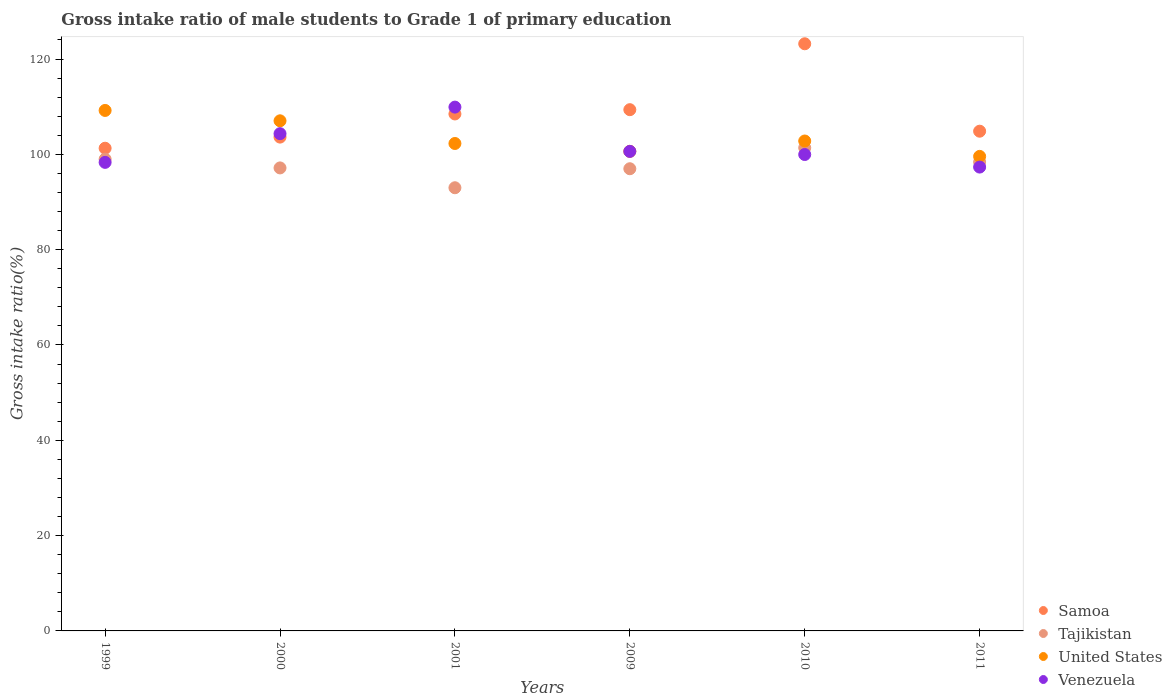How many different coloured dotlines are there?
Ensure brevity in your answer.  4. What is the gross intake ratio in Samoa in 2011?
Make the answer very short. 104.86. Across all years, what is the maximum gross intake ratio in United States?
Give a very brief answer. 109.21. Across all years, what is the minimum gross intake ratio in Samoa?
Your answer should be compact. 101.29. In which year was the gross intake ratio in Venezuela maximum?
Your response must be concise. 2001. In which year was the gross intake ratio in Samoa minimum?
Make the answer very short. 1999. What is the total gross intake ratio in Samoa in the graph?
Make the answer very short. 650.83. What is the difference between the gross intake ratio in Samoa in 2000 and that in 2001?
Your answer should be compact. -4.86. What is the difference between the gross intake ratio in Tajikistan in 1999 and the gross intake ratio in Samoa in 2010?
Provide a succinct answer. -24.21. What is the average gross intake ratio in United States per year?
Give a very brief answer. 103.59. In the year 1999, what is the difference between the gross intake ratio in Tajikistan and gross intake ratio in United States?
Your answer should be very brief. -10.22. In how many years, is the gross intake ratio in Tajikistan greater than 20 %?
Ensure brevity in your answer.  6. What is the ratio of the gross intake ratio in Venezuela in 2001 to that in 2009?
Keep it short and to the point. 1.09. Is the gross intake ratio in United States in 2009 less than that in 2010?
Provide a succinct answer. Yes. Is the difference between the gross intake ratio in Tajikistan in 1999 and 2000 greater than the difference between the gross intake ratio in United States in 1999 and 2000?
Give a very brief answer. No. What is the difference between the highest and the second highest gross intake ratio in Tajikistan?
Offer a terse response. 2.38. What is the difference between the highest and the lowest gross intake ratio in Samoa?
Offer a very short reply. 21.92. Is the sum of the gross intake ratio in Samoa in 1999 and 2011 greater than the maximum gross intake ratio in Venezuela across all years?
Your answer should be compact. Yes. Is it the case that in every year, the sum of the gross intake ratio in Samoa and gross intake ratio in Venezuela  is greater than the sum of gross intake ratio in Tajikistan and gross intake ratio in United States?
Keep it short and to the point. No. How many dotlines are there?
Offer a very short reply. 4. How many years are there in the graph?
Ensure brevity in your answer.  6. Are the values on the major ticks of Y-axis written in scientific E-notation?
Give a very brief answer. No. Does the graph contain grids?
Ensure brevity in your answer.  No. How are the legend labels stacked?
Provide a short and direct response. Vertical. What is the title of the graph?
Give a very brief answer. Gross intake ratio of male students to Grade 1 of primary education. What is the label or title of the Y-axis?
Offer a terse response. Gross intake ratio(%). What is the Gross intake ratio(%) in Samoa in 1999?
Keep it short and to the point. 101.29. What is the Gross intake ratio(%) of Tajikistan in 1999?
Offer a terse response. 98.99. What is the Gross intake ratio(%) of United States in 1999?
Your answer should be very brief. 109.21. What is the Gross intake ratio(%) of Venezuela in 1999?
Make the answer very short. 98.32. What is the Gross intake ratio(%) in Samoa in 2000?
Your answer should be compact. 103.62. What is the Gross intake ratio(%) of Tajikistan in 2000?
Provide a succinct answer. 97.15. What is the Gross intake ratio(%) in United States in 2000?
Make the answer very short. 107.04. What is the Gross intake ratio(%) in Venezuela in 2000?
Provide a succinct answer. 104.34. What is the Gross intake ratio(%) in Samoa in 2001?
Your answer should be compact. 108.48. What is the Gross intake ratio(%) in Tajikistan in 2001?
Keep it short and to the point. 92.99. What is the Gross intake ratio(%) in United States in 2001?
Ensure brevity in your answer.  102.28. What is the Gross intake ratio(%) of Venezuela in 2001?
Provide a short and direct response. 109.91. What is the Gross intake ratio(%) in Samoa in 2009?
Keep it short and to the point. 109.38. What is the Gross intake ratio(%) of Tajikistan in 2009?
Your answer should be compact. 96.98. What is the Gross intake ratio(%) in United States in 2009?
Offer a very short reply. 100.63. What is the Gross intake ratio(%) of Venezuela in 2009?
Give a very brief answer. 100.62. What is the Gross intake ratio(%) of Samoa in 2010?
Offer a terse response. 123.2. What is the Gross intake ratio(%) in Tajikistan in 2010?
Provide a succinct answer. 101.38. What is the Gross intake ratio(%) of United States in 2010?
Offer a terse response. 102.8. What is the Gross intake ratio(%) of Venezuela in 2010?
Give a very brief answer. 99.97. What is the Gross intake ratio(%) of Samoa in 2011?
Give a very brief answer. 104.86. What is the Gross intake ratio(%) of Tajikistan in 2011?
Offer a very short reply. 98.4. What is the Gross intake ratio(%) of United States in 2011?
Offer a terse response. 99.57. What is the Gross intake ratio(%) in Venezuela in 2011?
Offer a very short reply. 97.33. Across all years, what is the maximum Gross intake ratio(%) of Samoa?
Ensure brevity in your answer.  123.2. Across all years, what is the maximum Gross intake ratio(%) of Tajikistan?
Your response must be concise. 101.38. Across all years, what is the maximum Gross intake ratio(%) of United States?
Provide a succinct answer. 109.21. Across all years, what is the maximum Gross intake ratio(%) in Venezuela?
Your response must be concise. 109.91. Across all years, what is the minimum Gross intake ratio(%) in Samoa?
Keep it short and to the point. 101.29. Across all years, what is the minimum Gross intake ratio(%) in Tajikistan?
Your answer should be very brief. 92.99. Across all years, what is the minimum Gross intake ratio(%) in United States?
Provide a succinct answer. 99.57. Across all years, what is the minimum Gross intake ratio(%) in Venezuela?
Keep it short and to the point. 97.33. What is the total Gross intake ratio(%) of Samoa in the graph?
Offer a very short reply. 650.83. What is the total Gross intake ratio(%) in Tajikistan in the graph?
Offer a very short reply. 585.9. What is the total Gross intake ratio(%) of United States in the graph?
Ensure brevity in your answer.  621.55. What is the total Gross intake ratio(%) of Venezuela in the graph?
Keep it short and to the point. 610.5. What is the difference between the Gross intake ratio(%) in Samoa in 1999 and that in 2000?
Your answer should be compact. -2.33. What is the difference between the Gross intake ratio(%) of Tajikistan in 1999 and that in 2000?
Your answer should be compact. 1.84. What is the difference between the Gross intake ratio(%) in United States in 1999 and that in 2000?
Keep it short and to the point. 2.17. What is the difference between the Gross intake ratio(%) of Venezuela in 1999 and that in 2000?
Your answer should be very brief. -6.02. What is the difference between the Gross intake ratio(%) in Samoa in 1999 and that in 2001?
Your answer should be compact. -7.19. What is the difference between the Gross intake ratio(%) of Tajikistan in 1999 and that in 2001?
Keep it short and to the point. 6. What is the difference between the Gross intake ratio(%) of United States in 1999 and that in 2001?
Give a very brief answer. 6.93. What is the difference between the Gross intake ratio(%) in Venezuela in 1999 and that in 2001?
Offer a terse response. -11.59. What is the difference between the Gross intake ratio(%) of Samoa in 1999 and that in 2009?
Your answer should be compact. -8.09. What is the difference between the Gross intake ratio(%) in Tajikistan in 1999 and that in 2009?
Provide a succinct answer. 2.01. What is the difference between the Gross intake ratio(%) in United States in 1999 and that in 2009?
Your response must be concise. 8.58. What is the difference between the Gross intake ratio(%) of Venezuela in 1999 and that in 2009?
Provide a succinct answer. -2.31. What is the difference between the Gross intake ratio(%) of Samoa in 1999 and that in 2010?
Make the answer very short. -21.92. What is the difference between the Gross intake ratio(%) in Tajikistan in 1999 and that in 2010?
Your answer should be very brief. -2.38. What is the difference between the Gross intake ratio(%) in United States in 1999 and that in 2010?
Offer a very short reply. 6.41. What is the difference between the Gross intake ratio(%) in Venezuela in 1999 and that in 2010?
Your answer should be compact. -1.65. What is the difference between the Gross intake ratio(%) of Samoa in 1999 and that in 2011?
Provide a succinct answer. -3.57. What is the difference between the Gross intake ratio(%) of Tajikistan in 1999 and that in 2011?
Your answer should be very brief. 0.6. What is the difference between the Gross intake ratio(%) in United States in 1999 and that in 2011?
Provide a short and direct response. 9.64. What is the difference between the Gross intake ratio(%) in Samoa in 2000 and that in 2001?
Ensure brevity in your answer.  -4.86. What is the difference between the Gross intake ratio(%) of Tajikistan in 2000 and that in 2001?
Give a very brief answer. 4.16. What is the difference between the Gross intake ratio(%) in United States in 2000 and that in 2001?
Your answer should be compact. 4.76. What is the difference between the Gross intake ratio(%) of Venezuela in 2000 and that in 2001?
Keep it short and to the point. -5.57. What is the difference between the Gross intake ratio(%) of Samoa in 2000 and that in 2009?
Provide a short and direct response. -5.75. What is the difference between the Gross intake ratio(%) of Tajikistan in 2000 and that in 2009?
Make the answer very short. 0.17. What is the difference between the Gross intake ratio(%) of United States in 2000 and that in 2009?
Provide a succinct answer. 6.41. What is the difference between the Gross intake ratio(%) of Venezuela in 2000 and that in 2009?
Your response must be concise. 3.72. What is the difference between the Gross intake ratio(%) of Samoa in 2000 and that in 2010?
Offer a terse response. -19.58. What is the difference between the Gross intake ratio(%) of Tajikistan in 2000 and that in 2010?
Your response must be concise. -4.22. What is the difference between the Gross intake ratio(%) in United States in 2000 and that in 2010?
Your answer should be very brief. 4.24. What is the difference between the Gross intake ratio(%) of Venezuela in 2000 and that in 2010?
Provide a short and direct response. 4.37. What is the difference between the Gross intake ratio(%) in Samoa in 2000 and that in 2011?
Give a very brief answer. -1.24. What is the difference between the Gross intake ratio(%) in Tajikistan in 2000 and that in 2011?
Your answer should be very brief. -1.24. What is the difference between the Gross intake ratio(%) of United States in 2000 and that in 2011?
Make the answer very short. 7.47. What is the difference between the Gross intake ratio(%) in Venezuela in 2000 and that in 2011?
Your answer should be very brief. 7.01. What is the difference between the Gross intake ratio(%) in Samoa in 2001 and that in 2009?
Provide a short and direct response. -0.9. What is the difference between the Gross intake ratio(%) in Tajikistan in 2001 and that in 2009?
Ensure brevity in your answer.  -3.99. What is the difference between the Gross intake ratio(%) in United States in 2001 and that in 2009?
Provide a short and direct response. 1.65. What is the difference between the Gross intake ratio(%) in Venezuela in 2001 and that in 2009?
Give a very brief answer. 9.29. What is the difference between the Gross intake ratio(%) of Samoa in 2001 and that in 2010?
Offer a very short reply. -14.73. What is the difference between the Gross intake ratio(%) in Tajikistan in 2001 and that in 2010?
Ensure brevity in your answer.  -8.38. What is the difference between the Gross intake ratio(%) in United States in 2001 and that in 2010?
Offer a terse response. -0.52. What is the difference between the Gross intake ratio(%) of Venezuela in 2001 and that in 2010?
Your response must be concise. 9.94. What is the difference between the Gross intake ratio(%) of Samoa in 2001 and that in 2011?
Offer a very short reply. 3.62. What is the difference between the Gross intake ratio(%) in Tajikistan in 2001 and that in 2011?
Ensure brevity in your answer.  -5.4. What is the difference between the Gross intake ratio(%) of United States in 2001 and that in 2011?
Make the answer very short. 2.71. What is the difference between the Gross intake ratio(%) of Venezuela in 2001 and that in 2011?
Provide a succinct answer. 12.58. What is the difference between the Gross intake ratio(%) of Samoa in 2009 and that in 2010?
Your answer should be very brief. -13.83. What is the difference between the Gross intake ratio(%) in Tajikistan in 2009 and that in 2010?
Offer a terse response. -4.39. What is the difference between the Gross intake ratio(%) of United States in 2009 and that in 2010?
Your answer should be compact. -2.17. What is the difference between the Gross intake ratio(%) of Venezuela in 2009 and that in 2010?
Keep it short and to the point. 0.66. What is the difference between the Gross intake ratio(%) of Samoa in 2009 and that in 2011?
Your answer should be very brief. 4.51. What is the difference between the Gross intake ratio(%) of Tajikistan in 2009 and that in 2011?
Keep it short and to the point. -1.41. What is the difference between the Gross intake ratio(%) in United States in 2009 and that in 2011?
Offer a very short reply. 1.06. What is the difference between the Gross intake ratio(%) in Venezuela in 2009 and that in 2011?
Provide a short and direct response. 3.29. What is the difference between the Gross intake ratio(%) of Samoa in 2010 and that in 2011?
Give a very brief answer. 18.34. What is the difference between the Gross intake ratio(%) in Tajikistan in 2010 and that in 2011?
Ensure brevity in your answer.  2.98. What is the difference between the Gross intake ratio(%) in United States in 2010 and that in 2011?
Offer a very short reply. 3.23. What is the difference between the Gross intake ratio(%) of Venezuela in 2010 and that in 2011?
Make the answer very short. 2.64. What is the difference between the Gross intake ratio(%) of Samoa in 1999 and the Gross intake ratio(%) of Tajikistan in 2000?
Keep it short and to the point. 4.13. What is the difference between the Gross intake ratio(%) of Samoa in 1999 and the Gross intake ratio(%) of United States in 2000?
Your response must be concise. -5.75. What is the difference between the Gross intake ratio(%) of Samoa in 1999 and the Gross intake ratio(%) of Venezuela in 2000?
Ensure brevity in your answer.  -3.05. What is the difference between the Gross intake ratio(%) in Tajikistan in 1999 and the Gross intake ratio(%) in United States in 2000?
Offer a very short reply. -8.05. What is the difference between the Gross intake ratio(%) of Tajikistan in 1999 and the Gross intake ratio(%) of Venezuela in 2000?
Make the answer very short. -5.35. What is the difference between the Gross intake ratio(%) in United States in 1999 and the Gross intake ratio(%) in Venezuela in 2000?
Keep it short and to the point. 4.87. What is the difference between the Gross intake ratio(%) of Samoa in 1999 and the Gross intake ratio(%) of Tajikistan in 2001?
Make the answer very short. 8.29. What is the difference between the Gross intake ratio(%) in Samoa in 1999 and the Gross intake ratio(%) in United States in 2001?
Provide a succinct answer. -0.99. What is the difference between the Gross intake ratio(%) in Samoa in 1999 and the Gross intake ratio(%) in Venezuela in 2001?
Provide a short and direct response. -8.62. What is the difference between the Gross intake ratio(%) in Tajikistan in 1999 and the Gross intake ratio(%) in United States in 2001?
Your response must be concise. -3.29. What is the difference between the Gross intake ratio(%) of Tajikistan in 1999 and the Gross intake ratio(%) of Venezuela in 2001?
Make the answer very short. -10.92. What is the difference between the Gross intake ratio(%) of United States in 1999 and the Gross intake ratio(%) of Venezuela in 2001?
Provide a short and direct response. -0.7. What is the difference between the Gross intake ratio(%) of Samoa in 1999 and the Gross intake ratio(%) of Tajikistan in 2009?
Your answer should be compact. 4.3. What is the difference between the Gross intake ratio(%) of Samoa in 1999 and the Gross intake ratio(%) of United States in 2009?
Make the answer very short. 0.65. What is the difference between the Gross intake ratio(%) of Samoa in 1999 and the Gross intake ratio(%) of Venezuela in 2009?
Give a very brief answer. 0.66. What is the difference between the Gross intake ratio(%) in Tajikistan in 1999 and the Gross intake ratio(%) in United States in 2009?
Give a very brief answer. -1.64. What is the difference between the Gross intake ratio(%) of Tajikistan in 1999 and the Gross intake ratio(%) of Venezuela in 2009?
Provide a short and direct response. -1.63. What is the difference between the Gross intake ratio(%) of United States in 1999 and the Gross intake ratio(%) of Venezuela in 2009?
Your answer should be very brief. 8.59. What is the difference between the Gross intake ratio(%) in Samoa in 1999 and the Gross intake ratio(%) in Tajikistan in 2010?
Ensure brevity in your answer.  -0.09. What is the difference between the Gross intake ratio(%) of Samoa in 1999 and the Gross intake ratio(%) of United States in 2010?
Your answer should be very brief. -1.51. What is the difference between the Gross intake ratio(%) of Samoa in 1999 and the Gross intake ratio(%) of Venezuela in 2010?
Your response must be concise. 1.32. What is the difference between the Gross intake ratio(%) in Tajikistan in 1999 and the Gross intake ratio(%) in United States in 2010?
Your response must be concise. -3.81. What is the difference between the Gross intake ratio(%) of Tajikistan in 1999 and the Gross intake ratio(%) of Venezuela in 2010?
Your answer should be very brief. -0.98. What is the difference between the Gross intake ratio(%) of United States in 1999 and the Gross intake ratio(%) of Venezuela in 2010?
Provide a short and direct response. 9.25. What is the difference between the Gross intake ratio(%) of Samoa in 1999 and the Gross intake ratio(%) of Tajikistan in 2011?
Provide a short and direct response. 2.89. What is the difference between the Gross intake ratio(%) of Samoa in 1999 and the Gross intake ratio(%) of United States in 2011?
Make the answer very short. 1.71. What is the difference between the Gross intake ratio(%) of Samoa in 1999 and the Gross intake ratio(%) of Venezuela in 2011?
Keep it short and to the point. 3.96. What is the difference between the Gross intake ratio(%) in Tajikistan in 1999 and the Gross intake ratio(%) in United States in 2011?
Keep it short and to the point. -0.58. What is the difference between the Gross intake ratio(%) in Tajikistan in 1999 and the Gross intake ratio(%) in Venezuela in 2011?
Offer a very short reply. 1.66. What is the difference between the Gross intake ratio(%) in United States in 1999 and the Gross intake ratio(%) in Venezuela in 2011?
Provide a short and direct response. 11.88. What is the difference between the Gross intake ratio(%) of Samoa in 2000 and the Gross intake ratio(%) of Tajikistan in 2001?
Make the answer very short. 10.63. What is the difference between the Gross intake ratio(%) of Samoa in 2000 and the Gross intake ratio(%) of United States in 2001?
Offer a terse response. 1.34. What is the difference between the Gross intake ratio(%) in Samoa in 2000 and the Gross intake ratio(%) in Venezuela in 2001?
Your response must be concise. -6.29. What is the difference between the Gross intake ratio(%) of Tajikistan in 2000 and the Gross intake ratio(%) of United States in 2001?
Provide a short and direct response. -5.13. What is the difference between the Gross intake ratio(%) of Tajikistan in 2000 and the Gross intake ratio(%) of Venezuela in 2001?
Provide a short and direct response. -12.76. What is the difference between the Gross intake ratio(%) in United States in 2000 and the Gross intake ratio(%) in Venezuela in 2001?
Provide a succinct answer. -2.87. What is the difference between the Gross intake ratio(%) in Samoa in 2000 and the Gross intake ratio(%) in Tajikistan in 2009?
Ensure brevity in your answer.  6.64. What is the difference between the Gross intake ratio(%) of Samoa in 2000 and the Gross intake ratio(%) of United States in 2009?
Offer a very short reply. 2.99. What is the difference between the Gross intake ratio(%) of Samoa in 2000 and the Gross intake ratio(%) of Venezuela in 2009?
Provide a short and direct response. 3. What is the difference between the Gross intake ratio(%) of Tajikistan in 2000 and the Gross intake ratio(%) of United States in 2009?
Ensure brevity in your answer.  -3.48. What is the difference between the Gross intake ratio(%) of Tajikistan in 2000 and the Gross intake ratio(%) of Venezuela in 2009?
Make the answer very short. -3.47. What is the difference between the Gross intake ratio(%) in United States in 2000 and the Gross intake ratio(%) in Venezuela in 2009?
Your response must be concise. 6.42. What is the difference between the Gross intake ratio(%) in Samoa in 2000 and the Gross intake ratio(%) in Tajikistan in 2010?
Offer a very short reply. 2.25. What is the difference between the Gross intake ratio(%) of Samoa in 2000 and the Gross intake ratio(%) of United States in 2010?
Your answer should be very brief. 0.82. What is the difference between the Gross intake ratio(%) of Samoa in 2000 and the Gross intake ratio(%) of Venezuela in 2010?
Your response must be concise. 3.65. What is the difference between the Gross intake ratio(%) of Tajikistan in 2000 and the Gross intake ratio(%) of United States in 2010?
Your answer should be compact. -5.65. What is the difference between the Gross intake ratio(%) in Tajikistan in 2000 and the Gross intake ratio(%) in Venezuela in 2010?
Make the answer very short. -2.81. What is the difference between the Gross intake ratio(%) in United States in 2000 and the Gross intake ratio(%) in Venezuela in 2010?
Ensure brevity in your answer.  7.07. What is the difference between the Gross intake ratio(%) in Samoa in 2000 and the Gross intake ratio(%) in Tajikistan in 2011?
Your answer should be very brief. 5.22. What is the difference between the Gross intake ratio(%) in Samoa in 2000 and the Gross intake ratio(%) in United States in 2011?
Your answer should be very brief. 4.05. What is the difference between the Gross intake ratio(%) in Samoa in 2000 and the Gross intake ratio(%) in Venezuela in 2011?
Provide a short and direct response. 6.29. What is the difference between the Gross intake ratio(%) of Tajikistan in 2000 and the Gross intake ratio(%) of United States in 2011?
Your answer should be compact. -2.42. What is the difference between the Gross intake ratio(%) in Tajikistan in 2000 and the Gross intake ratio(%) in Venezuela in 2011?
Make the answer very short. -0.18. What is the difference between the Gross intake ratio(%) of United States in 2000 and the Gross intake ratio(%) of Venezuela in 2011?
Provide a succinct answer. 9.71. What is the difference between the Gross intake ratio(%) in Samoa in 2001 and the Gross intake ratio(%) in Tajikistan in 2009?
Provide a short and direct response. 11.49. What is the difference between the Gross intake ratio(%) in Samoa in 2001 and the Gross intake ratio(%) in United States in 2009?
Provide a succinct answer. 7.84. What is the difference between the Gross intake ratio(%) of Samoa in 2001 and the Gross intake ratio(%) of Venezuela in 2009?
Ensure brevity in your answer.  7.85. What is the difference between the Gross intake ratio(%) of Tajikistan in 2001 and the Gross intake ratio(%) of United States in 2009?
Make the answer very short. -7.64. What is the difference between the Gross intake ratio(%) of Tajikistan in 2001 and the Gross intake ratio(%) of Venezuela in 2009?
Your answer should be compact. -7.63. What is the difference between the Gross intake ratio(%) in United States in 2001 and the Gross intake ratio(%) in Venezuela in 2009?
Keep it short and to the point. 1.66. What is the difference between the Gross intake ratio(%) in Samoa in 2001 and the Gross intake ratio(%) in Tajikistan in 2010?
Offer a terse response. 7.1. What is the difference between the Gross intake ratio(%) in Samoa in 2001 and the Gross intake ratio(%) in United States in 2010?
Your response must be concise. 5.68. What is the difference between the Gross intake ratio(%) of Samoa in 2001 and the Gross intake ratio(%) of Venezuela in 2010?
Your response must be concise. 8.51. What is the difference between the Gross intake ratio(%) of Tajikistan in 2001 and the Gross intake ratio(%) of United States in 2010?
Keep it short and to the point. -9.81. What is the difference between the Gross intake ratio(%) in Tajikistan in 2001 and the Gross intake ratio(%) in Venezuela in 2010?
Provide a succinct answer. -6.97. What is the difference between the Gross intake ratio(%) in United States in 2001 and the Gross intake ratio(%) in Venezuela in 2010?
Keep it short and to the point. 2.31. What is the difference between the Gross intake ratio(%) of Samoa in 2001 and the Gross intake ratio(%) of Tajikistan in 2011?
Keep it short and to the point. 10.08. What is the difference between the Gross intake ratio(%) of Samoa in 2001 and the Gross intake ratio(%) of United States in 2011?
Provide a short and direct response. 8.9. What is the difference between the Gross intake ratio(%) of Samoa in 2001 and the Gross intake ratio(%) of Venezuela in 2011?
Provide a succinct answer. 11.15. What is the difference between the Gross intake ratio(%) of Tajikistan in 2001 and the Gross intake ratio(%) of United States in 2011?
Offer a very short reply. -6.58. What is the difference between the Gross intake ratio(%) of Tajikistan in 2001 and the Gross intake ratio(%) of Venezuela in 2011?
Offer a terse response. -4.34. What is the difference between the Gross intake ratio(%) of United States in 2001 and the Gross intake ratio(%) of Venezuela in 2011?
Provide a short and direct response. 4.95. What is the difference between the Gross intake ratio(%) in Samoa in 2009 and the Gross intake ratio(%) in Tajikistan in 2010?
Keep it short and to the point. 8. What is the difference between the Gross intake ratio(%) of Samoa in 2009 and the Gross intake ratio(%) of United States in 2010?
Make the answer very short. 6.57. What is the difference between the Gross intake ratio(%) in Samoa in 2009 and the Gross intake ratio(%) in Venezuela in 2010?
Offer a terse response. 9.41. What is the difference between the Gross intake ratio(%) of Tajikistan in 2009 and the Gross intake ratio(%) of United States in 2010?
Ensure brevity in your answer.  -5.82. What is the difference between the Gross intake ratio(%) in Tajikistan in 2009 and the Gross intake ratio(%) in Venezuela in 2010?
Provide a short and direct response. -2.99. What is the difference between the Gross intake ratio(%) in United States in 2009 and the Gross intake ratio(%) in Venezuela in 2010?
Keep it short and to the point. 0.67. What is the difference between the Gross intake ratio(%) of Samoa in 2009 and the Gross intake ratio(%) of Tajikistan in 2011?
Give a very brief answer. 10.98. What is the difference between the Gross intake ratio(%) of Samoa in 2009 and the Gross intake ratio(%) of United States in 2011?
Ensure brevity in your answer.  9.8. What is the difference between the Gross intake ratio(%) in Samoa in 2009 and the Gross intake ratio(%) in Venezuela in 2011?
Your answer should be very brief. 12.04. What is the difference between the Gross intake ratio(%) of Tajikistan in 2009 and the Gross intake ratio(%) of United States in 2011?
Offer a very short reply. -2.59. What is the difference between the Gross intake ratio(%) in Tajikistan in 2009 and the Gross intake ratio(%) in Venezuela in 2011?
Offer a very short reply. -0.35. What is the difference between the Gross intake ratio(%) in United States in 2009 and the Gross intake ratio(%) in Venezuela in 2011?
Provide a short and direct response. 3.3. What is the difference between the Gross intake ratio(%) of Samoa in 2010 and the Gross intake ratio(%) of Tajikistan in 2011?
Give a very brief answer. 24.81. What is the difference between the Gross intake ratio(%) of Samoa in 2010 and the Gross intake ratio(%) of United States in 2011?
Keep it short and to the point. 23.63. What is the difference between the Gross intake ratio(%) in Samoa in 2010 and the Gross intake ratio(%) in Venezuela in 2011?
Provide a short and direct response. 25.87. What is the difference between the Gross intake ratio(%) in Tajikistan in 2010 and the Gross intake ratio(%) in United States in 2011?
Provide a succinct answer. 1.8. What is the difference between the Gross intake ratio(%) of Tajikistan in 2010 and the Gross intake ratio(%) of Venezuela in 2011?
Offer a terse response. 4.04. What is the difference between the Gross intake ratio(%) in United States in 2010 and the Gross intake ratio(%) in Venezuela in 2011?
Make the answer very short. 5.47. What is the average Gross intake ratio(%) in Samoa per year?
Ensure brevity in your answer.  108.47. What is the average Gross intake ratio(%) of Tajikistan per year?
Your answer should be compact. 97.65. What is the average Gross intake ratio(%) in United States per year?
Ensure brevity in your answer.  103.59. What is the average Gross intake ratio(%) of Venezuela per year?
Make the answer very short. 101.75. In the year 1999, what is the difference between the Gross intake ratio(%) of Samoa and Gross intake ratio(%) of Tajikistan?
Your answer should be very brief. 2.3. In the year 1999, what is the difference between the Gross intake ratio(%) of Samoa and Gross intake ratio(%) of United States?
Provide a short and direct response. -7.93. In the year 1999, what is the difference between the Gross intake ratio(%) of Samoa and Gross intake ratio(%) of Venezuela?
Your response must be concise. 2.97. In the year 1999, what is the difference between the Gross intake ratio(%) of Tajikistan and Gross intake ratio(%) of United States?
Your answer should be very brief. -10.22. In the year 1999, what is the difference between the Gross intake ratio(%) in Tajikistan and Gross intake ratio(%) in Venezuela?
Your answer should be very brief. 0.67. In the year 1999, what is the difference between the Gross intake ratio(%) of United States and Gross intake ratio(%) of Venezuela?
Your answer should be compact. 10.9. In the year 2000, what is the difference between the Gross intake ratio(%) in Samoa and Gross intake ratio(%) in Tajikistan?
Your answer should be very brief. 6.47. In the year 2000, what is the difference between the Gross intake ratio(%) in Samoa and Gross intake ratio(%) in United States?
Provide a short and direct response. -3.42. In the year 2000, what is the difference between the Gross intake ratio(%) of Samoa and Gross intake ratio(%) of Venezuela?
Your response must be concise. -0.72. In the year 2000, what is the difference between the Gross intake ratio(%) in Tajikistan and Gross intake ratio(%) in United States?
Your response must be concise. -9.88. In the year 2000, what is the difference between the Gross intake ratio(%) of Tajikistan and Gross intake ratio(%) of Venezuela?
Offer a terse response. -7.19. In the year 2000, what is the difference between the Gross intake ratio(%) of United States and Gross intake ratio(%) of Venezuela?
Your response must be concise. 2.7. In the year 2001, what is the difference between the Gross intake ratio(%) in Samoa and Gross intake ratio(%) in Tajikistan?
Give a very brief answer. 15.48. In the year 2001, what is the difference between the Gross intake ratio(%) in Samoa and Gross intake ratio(%) in United States?
Offer a terse response. 6.2. In the year 2001, what is the difference between the Gross intake ratio(%) in Samoa and Gross intake ratio(%) in Venezuela?
Provide a short and direct response. -1.43. In the year 2001, what is the difference between the Gross intake ratio(%) of Tajikistan and Gross intake ratio(%) of United States?
Your response must be concise. -9.29. In the year 2001, what is the difference between the Gross intake ratio(%) of Tajikistan and Gross intake ratio(%) of Venezuela?
Your response must be concise. -16.92. In the year 2001, what is the difference between the Gross intake ratio(%) of United States and Gross intake ratio(%) of Venezuela?
Keep it short and to the point. -7.63. In the year 2009, what is the difference between the Gross intake ratio(%) in Samoa and Gross intake ratio(%) in Tajikistan?
Your answer should be very brief. 12.39. In the year 2009, what is the difference between the Gross intake ratio(%) in Samoa and Gross intake ratio(%) in United States?
Keep it short and to the point. 8.74. In the year 2009, what is the difference between the Gross intake ratio(%) of Samoa and Gross intake ratio(%) of Venezuela?
Give a very brief answer. 8.75. In the year 2009, what is the difference between the Gross intake ratio(%) of Tajikistan and Gross intake ratio(%) of United States?
Offer a very short reply. -3.65. In the year 2009, what is the difference between the Gross intake ratio(%) of Tajikistan and Gross intake ratio(%) of Venezuela?
Your response must be concise. -3.64. In the year 2009, what is the difference between the Gross intake ratio(%) in United States and Gross intake ratio(%) in Venezuela?
Make the answer very short. 0.01. In the year 2010, what is the difference between the Gross intake ratio(%) in Samoa and Gross intake ratio(%) in Tajikistan?
Keep it short and to the point. 21.83. In the year 2010, what is the difference between the Gross intake ratio(%) in Samoa and Gross intake ratio(%) in United States?
Ensure brevity in your answer.  20.4. In the year 2010, what is the difference between the Gross intake ratio(%) in Samoa and Gross intake ratio(%) in Venezuela?
Ensure brevity in your answer.  23.24. In the year 2010, what is the difference between the Gross intake ratio(%) in Tajikistan and Gross intake ratio(%) in United States?
Your response must be concise. -1.43. In the year 2010, what is the difference between the Gross intake ratio(%) of Tajikistan and Gross intake ratio(%) of Venezuela?
Your answer should be very brief. 1.41. In the year 2010, what is the difference between the Gross intake ratio(%) in United States and Gross intake ratio(%) in Venezuela?
Give a very brief answer. 2.83. In the year 2011, what is the difference between the Gross intake ratio(%) of Samoa and Gross intake ratio(%) of Tajikistan?
Your answer should be compact. 6.46. In the year 2011, what is the difference between the Gross intake ratio(%) of Samoa and Gross intake ratio(%) of United States?
Your answer should be compact. 5.29. In the year 2011, what is the difference between the Gross intake ratio(%) of Samoa and Gross intake ratio(%) of Venezuela?
Make the answer very short. 7.53. In the year 2011, what is the difference between the Gross intake ratio(%) of Tajikistan and Gross intake ratio(%) of United States?
Provide a short and direct response. -1.18. In the year 2011, what is the difference between the Gross intake ratio(%) of Tajikistan and Gross intake ratio(%) of Venezuela?
Your answer should be compact. 1.07. In the year 2011, what is the difference between the Gross intake ratio(%) in United States and Gross intake ratio(%) in Venezuela?
Keep it short and to the point. 2.24. What is the ratio of the Gross intake ratio(%) in Samoa in 1999 to that in 2000?
Provide a succinct answer. 0.98. What is the ratio of the Gross intake ratio(%) in Tajikistan in 1999 to that in 2000?
Offer a very short reply. 1.02. What is the ratio of the Gross intake ratio(%) of United States in 1999 to that in 2000?
Your answer should be very brief. 1.02. What is the ratio of the Gross intake ratio(%) in Venezuela in 1999 to that in 2000?
Your answer should be compact. 0.94. What is the ratio of the Gross intake ratio(%) of Samoa in 1999 to that in 2001?
Your response must be concise. 0.93. What is the ratio of the Gross intake ratio(%) in Tajikistan in 1999 to that in 2001?
Ensure brevity in your answer.  1.06. What is the ratio of the Gross intake ratio(%) of United States in 1999 to that in 2001?
Your answer should be compact. 1.07. What is the ratio of the Gross intake ratio(%) in Venezuela in 1999 to that in 2001?
Offer a terse response. 0.89. What is the ratio of the Gross intake ratio(%) of Samoa in 1999 to that in 2009?
Give a very brief answer. 0.93. What is the ratio of the Gross intake ratio(%) of Tajikistan in 1999 to that in 2009?
Make the answer very short. 1.02. What is the ratio of the Gross intake ratio(%) in United States in 1999 to that in 2009?
Keep it short and to the point. 1.09. What is the ratio of the Gross intake ratio(%) in Venezuela in 1999 to that in 2009?
Your answer should be very brief. 0.98. What is the ratio of the Gross intake ratio(%) in Samoa in 1999 to that in 2010?
Keep it short and to the point. 0.82. What is the ratio of the Gross intake ratio(%) in Tajikistan in 1999 to that in 2010?
Provide a short and direct response. 0.98. What is the ratio of the Gross intake ratio(%) of United States in 1999 to that in 2010?
Offer a very short reply. 1.06. What is the ratio of the Gross intake ratio(%) of Venezuela in 1999 to that in 2010?
Provide a short and direct response. 0.98. What is the ratio of the Gross intake ratio(%) in Samoa in 1999 to that in 2011?
Your answer should be compact. 0.97. What is the ratio of the Gross intake ratio(%) of United States in 1999 to that in 2011?
Provide a short and direct response. 1.1. What is the ratio of the Gross intake ratio(%) in Venezuela in 1999 to that in 2011?
Give a very brief answer. 1.01. What is the ratio of the Gross intake ratio(%) of Samoa in 2000 to that in 2001?
Offer a very short reply. 0.96. What is the ratio of the Gross intake ratio(%) of Tajikistan in 2000 to that in 2001?
Provide a short and direct response. 1.04. What is the ratio of the Gross intake ratio(%) in United States in 2000 to that in 2001?
Ensure brevity in your answer.  1.05. What is the ratio of the Gross intake ratio(%) in Venezuela in 2000 to that in 2001?
Ensure brevity in your answer.  0.95. What is the ratio of the Gross intake ratio(%) of Samoa in 2000 to that in 2009?
Your answer should be very brief. 0.95. What is the ratio of the Gross intake ratio(%) of Tajikistan in 2000 to that in 2009?
Make the answer very short. 1. What is the ratio of the Gross intake ratio(%) of United States in 2000 to that in 2009?
Give a very brief answer. 1.06. What is the ratio of the Gross intake ratio(%) of Venezuela in 2000 to that in 2009?
Give a very brief answer. 1.04. What is the ratio of the Gross intake ratio(%) in Samoa in 2000 to that in 2010?
Your response must be concise. 0.84. What is the ratio of the Gross intake ratio(%) in Tajikistan in 2000 to that in 2010?
Your response must be concise. 0.96. What is the ratio of the Gross intake ratio(%) of United States in 2000 to that in 2010?
Offer a terse response. 1.04. What is the ratio of the Gross intake ratio(%) in Venezuela in 2000 to that in 2010?
Give a very brief answer. 1.04. What is the ratio of the Gross intake ratio(%) in Tajikistan in 2000 to that in 2011?
Provide a short and direct response. 0.99. What is the ratio of the Gross intake ratio(%) in United States in 2000 to that in 2011?
Provide a short and direct response. 1.07. What is the ratio of the Gross intake ratio(%) of Venezuela in 2000 to that in 2011?
Ensure brevity in your answer.  1.07. What is the ratio of the Gross intake ratio(%) of Samoa in 2001 to that in 2009?
Your response must be concise. 0.99. What is the ratio of the Gross intake ratio(%) of Tajikistan in 2001 to that in 2009?
Your answer should be very brief. 0.96. What is the ratio of the Gross intake ratio(%) of United States in 2001 to that in 2009?
Ensure brevity in your answer.  1.02. What is the ratio of the Gross intake ratio(%) of Venezuela in 2001 to that in 2009?
Your answer should be very brief. 1.09. What is the ratio of the Gross intake ratio(%) in Samoa in 2001 to that in 2010?
Your response must be concise. 0.88. What is the ratio of the Gross intake ratio(%) of Tajikistan in 2001 to that in 2010?
Provide a short and direct response. 0.92. What is the ratio of the Gross intake ratio(%) in United States in 2001 to that in 2010?
Provide a succinct answer. 0.99. What is the ratio of the Gross intake ratio(%) of Venezuela in 2001 to that in 2010?
Offer a terse response. 1.1. What is the ratio of the Gross intake ratio(%) in Samoa in 2001 to that in 2011?
Give a very brief answer. 1.03. What is the ratio of the Gross intake ratio(%) of Tajikistan in 2001 to that in 2011?
Your answer should be very brief. 0.95. What is the ratio of the Gross intake ratio(%) in United States in 2001 to that in 2011?
Your answer should be very brief. 1.03. What is the ratio of the Gross intake ratio(%) in Venezuela in 2001 to that in 2011?
Provide a short and direct response. 1.13. What is the ratio of the Gross intake ratio(%) in Samoa in 2009 to that in 2010?
Keep it short and to the point. 0.89. What is the ratio of the Gross intake ratio(%) in Tajikistan in 2009 to that in 2010?
Your answer should be compact. 0.96. What is the ratio of the Gross intake ratio(%) of United States in 2009 to that in 2010?
Your answer should be very brief. 0.98. What is the ratio of the Gross intake ratio(%) in Venezuela in 2009 to that in 2010?
Keep it short and to the point. 1.01. What is the ratio of the Gross intake ratio(%) in Samoa in 2009 to that in 2011?
Keep it short and to the point. 1.04. What is the ratio of the Gross intake ratio(%) of Tajikistan in 2009 to that in 2011?
Give a very brief answer. 0.99. What is the ratio of the Gross intake ratio(%) of United States in 2009 to that in 2011?
Offer a terse response. 1.01. What is the ratio of the Gross intake ratio(%) of Venezuela in 2009 to that in 2011?
Your answer should be compact. 1.03. What is the ratio of the Gross intake ratio(%) of Samoa in 2010 to that in 2011?
Your answer should be compact. 1.17. What is the ratio of the Gross intake ratio(%) in Tajikistan in 2010 to that in 2011?
Keep it short and to the point. 1.03. What is the ratio of the Gross intake ratio(%) of United States in 2010 to that in 2011?
Ensure brevity in your answer.  1.03. What is the ratio of the Gross intake ratio(%) in Venezuela in 2010 to that in 2011?
Your answer should be compact. 1.03. What is the difference between the highest and the second highest Gross intake ratio(%) of Samoa?
Offer a terse response. 13.83. What is the difference between the highest and the second highest Gross intake ratio(%) of Tajikistan?
Offer a terse response. 2.38. What is the difference between the highest and the second highest Gross intake ratio(%) of United States?
Provide a short and direct response. 2.17. What is the difference between the highest and the second highest Gross intake ratio(%) in Venezuela?
Your response must be concise. 5.57. What is the difference between the highest and the lowest Gross intake ratio(%) of Samoa?
Your response must be concise. 21.92. What is the difference between the highest and the lowest Gross intake ratio(%) of Tajikistan?
Ensure brevity in your answer.  8.38. What is the difference between the highest and the lowest Gross intake ratio(%) in United States?
Provide a succinct answer. 9.64. What is the difference between the highest and the lowest Gross intake ratio(%) of Venezuela?
Provide a succinct answer. 12.58. 